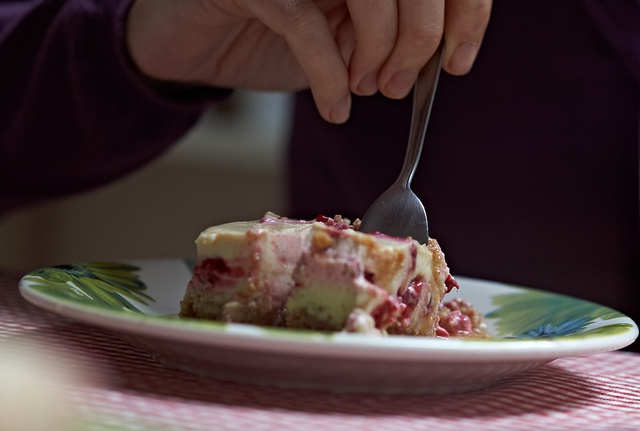Describe the objects in this image and their specific colors. I can see dining table in black, maroon, darkgray, and gray tones, people in black, maroon, and brown tones, cake in black, maroon, gray, and darkgray tones, and fork in black and gray tones in this image. 